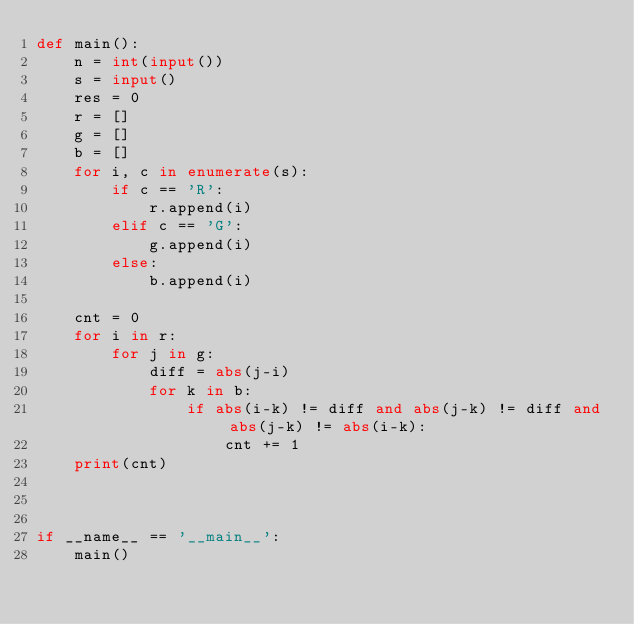<code> <loc_0><loc_0><loc_500><loc_500><_Python_>def main():
    n = int(input())
    s = input()
    res = 0
    r = []
    g = []
    b = []
    for i, c in enumerate(s):
        if c == 'R':
            r.append(i)
        elif c == 'G':
            g.append(i)
        else:
            b.append(i)
    
    cnt = 0
    for i in r:
        for j in g:
            diff = abs(j-i)
            for k in b:
                if abs(i-k) != diff and abs(j-k) != diff and abs(j-k) != abs(i-k):
                    cnt += 1
    print(cnt)
                    


if __name__ == '__main__':
    main()

</code> 